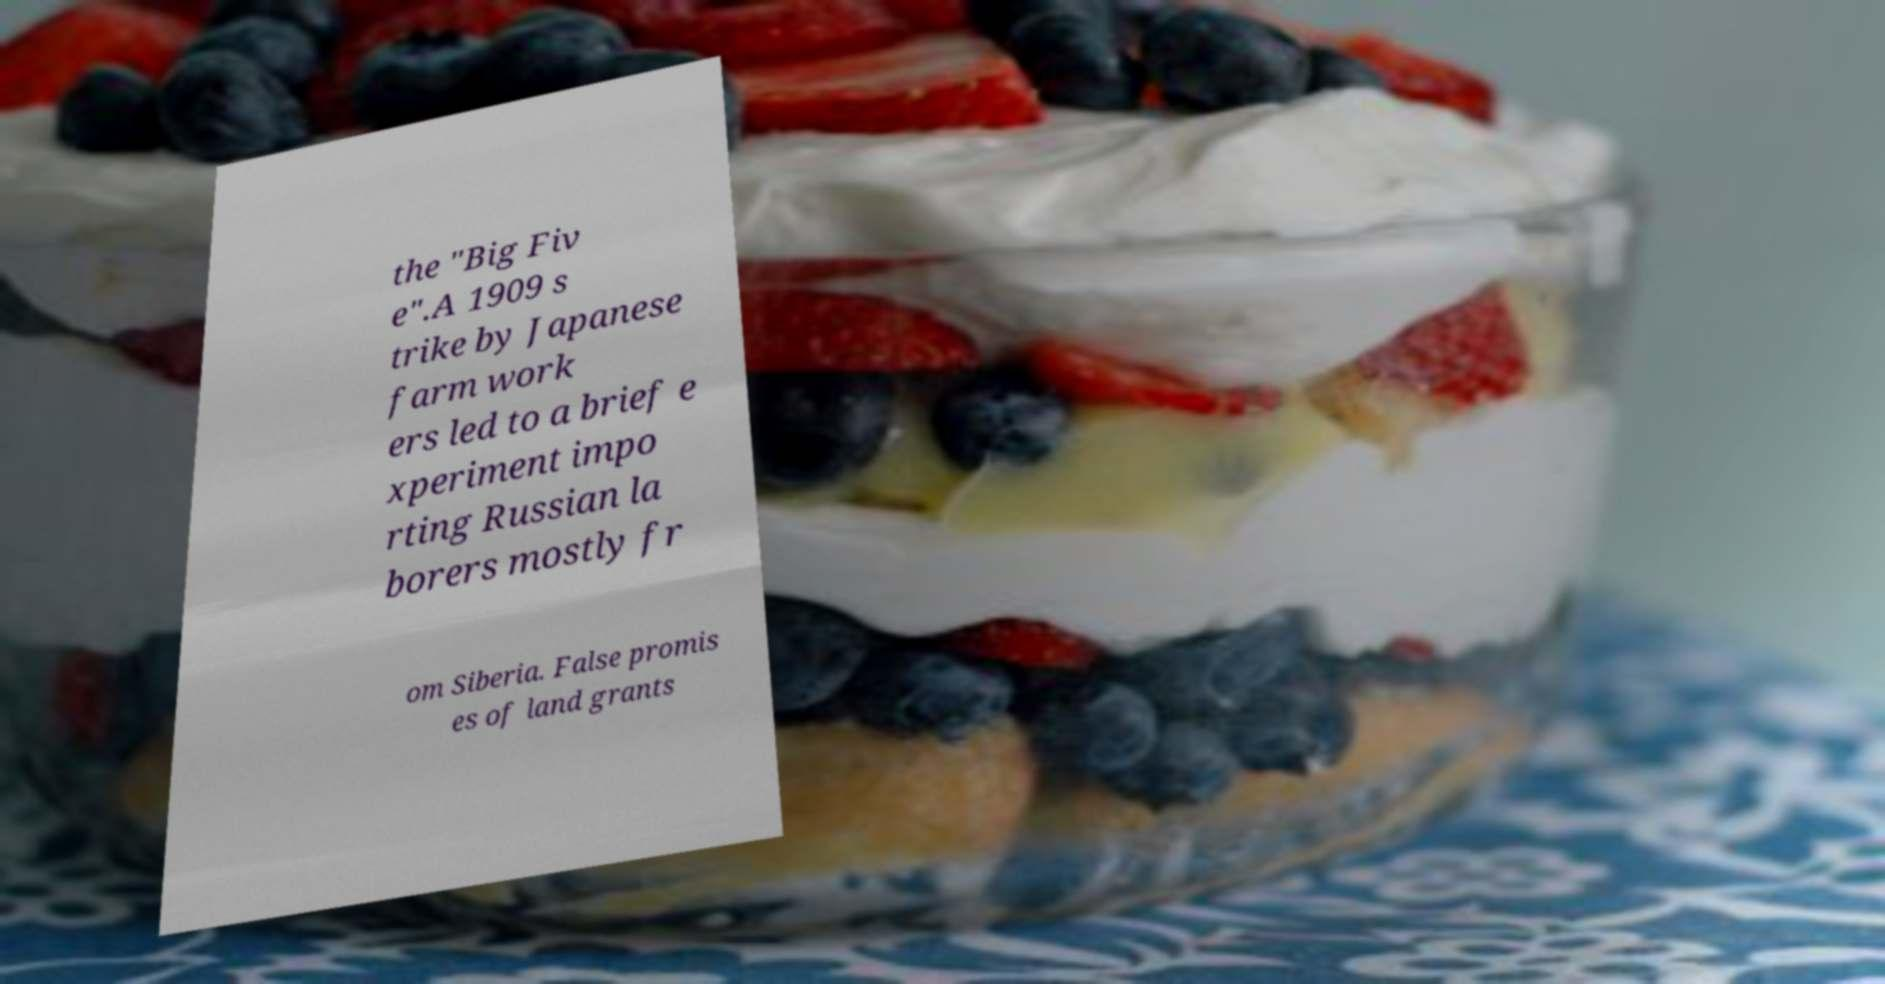Can you read and provide the text displayed in the image?This photo seems to have some interesting text. Can you extract and type it out for me? the "Big Fiv e".A 1909 s trike by Japanese farm work ers led to a brief e xperiment impo rting Russian la borers mostly fr om Siberia. False promis es of land grants 